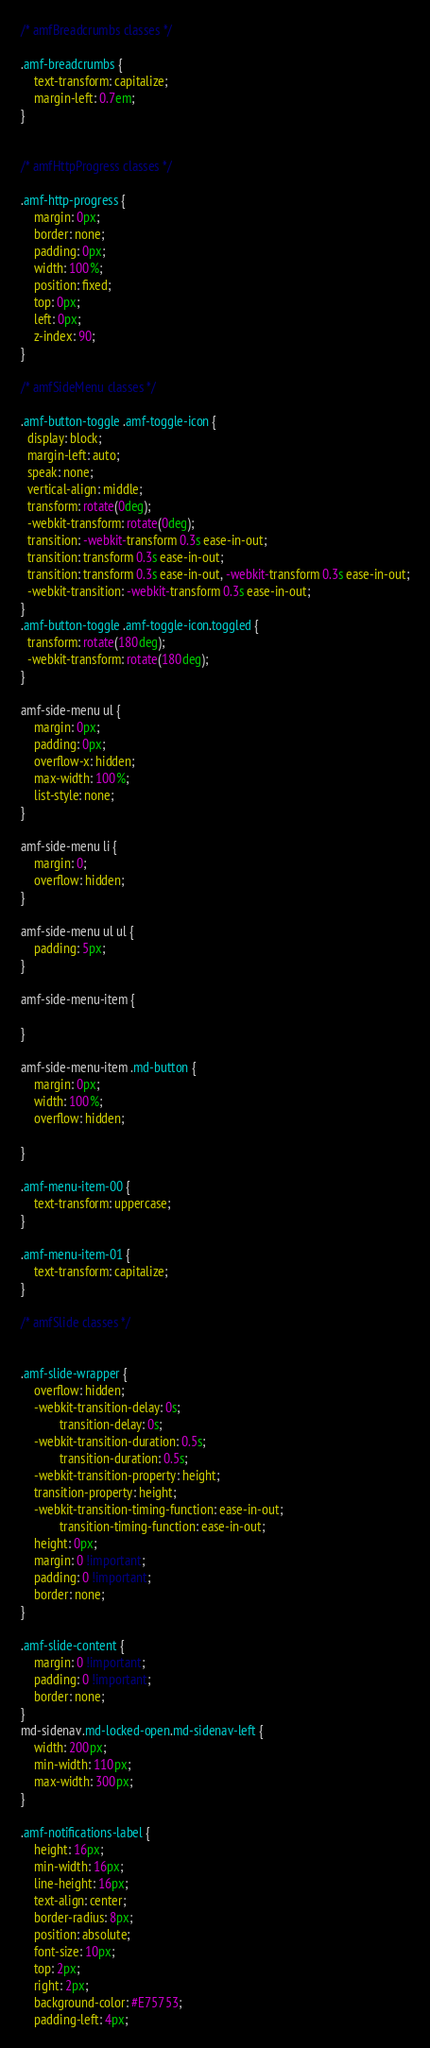Convert code to text. <code><loc_0><loc_0><loc_500><loc_500><_CSS_>/* amfBreadcrumbs classes */

.amf-breadcrumbs {
	text-transform: capitalize;
	margin-left: 0.7em;
}


/* amfHttpProgress classes */

.amf-http-progress {
	margin: 0px;
	border: none;
	padding: 0px;
	width: 100%;
	position: fixed;
	top: 0px;
	left: 0px;
	z-index: 90;
}

/* amfSideMenu classes */

.amf-button-toggle .amf-toggle-icon {
  display: block;
  margin-left: auto;
  speak: none;
  vertical-align: middle;
  transform: rotate(0deg);
  -webkit-transform: rotate(0deg);
  transition: -webkit-transform 0.3s ease-in-out;
  transition: transform 0.3s ease-in-out;
  transition: transform 0.3s ease-in-out, -webkit-transform 0.3s ease-in-out;
  -webkit-transition: -webkit-transform 0.3s ease-in-out;
}
.amf-button-toggle .amf-toggle-icon.toggled {
  transform: rotate(180deg);
  -webkit-transform: rotate(180deg);
}

amf-side-menu ul {
	margin: 0px;
	padding: 0px;
	overflow-x: hidden;
	max-width: 100%;
	list-style: none;
}

amf-side-menu li {
	margin: 0;
	overflow: hidden;
}

amf-side-menu ul ul {
	padding: 5px;
}

amf-side-menu-item {
	
}

amf-side-menu-item .md-button {
	margin: 0px;
	width: 100%;
	overflow: hidden;
	
}

.amf-menu-item-00 {
	text-transform: uppercase;
}

.amf-menu-item-01 {
	text-transform: capitalize;
}

/* amfSlide classes */


.amf-slide-wrapper {
	overflow: hidden;
	-webkit-transition-delay: 0s;
	        transition-delay: 0s;
	-webkit-transition-duration: 0.5s;
	        transition-duration: 0.5s;
	-webkit-transition-property: height;
	transition-property: height;
	-webkit-transition-timing-function: ease-in-out;
	        transition-timing-function: ease-in-out;
	height: 0px;
	margin: 0 !important;
	padding: 0 !important;
	border: none;
}

.amf-slide-content {
	margin: 0 !important;
	padding: 0 !important;
	border: none;
}
md-sidenav.md-locked-open.md-sidenav-left {
	width: 200px;
	min-width: 110px;
	max-width: 300px;
}

.amf-notifications-label {
	height: 16px;
	min-width: 16px;
	line-height: 16px;
	text-align: center;
	border-radius: 8px;
	position: absolute;
	font-size: 10px;
	top: 2px;
	right: 2px;
	background-color: #E75753;
	padding-left: 4px;</code> 